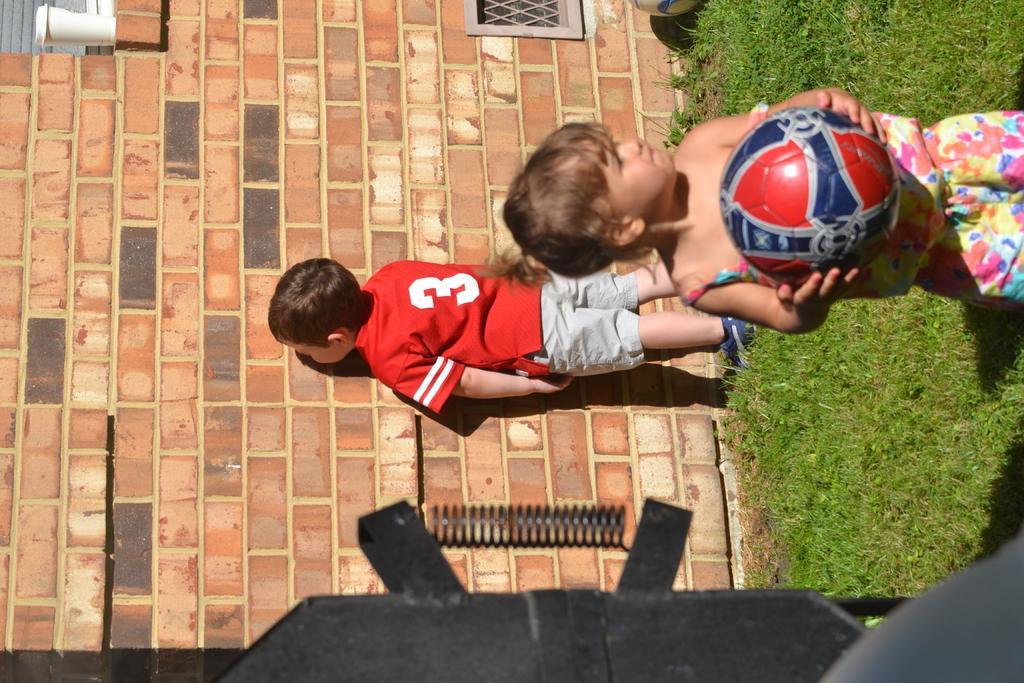Describe this image in one or two sentences. In this picture we can see the grass, ball, girl, boy, glass, spring and some objects and in the background we can see the wall. 